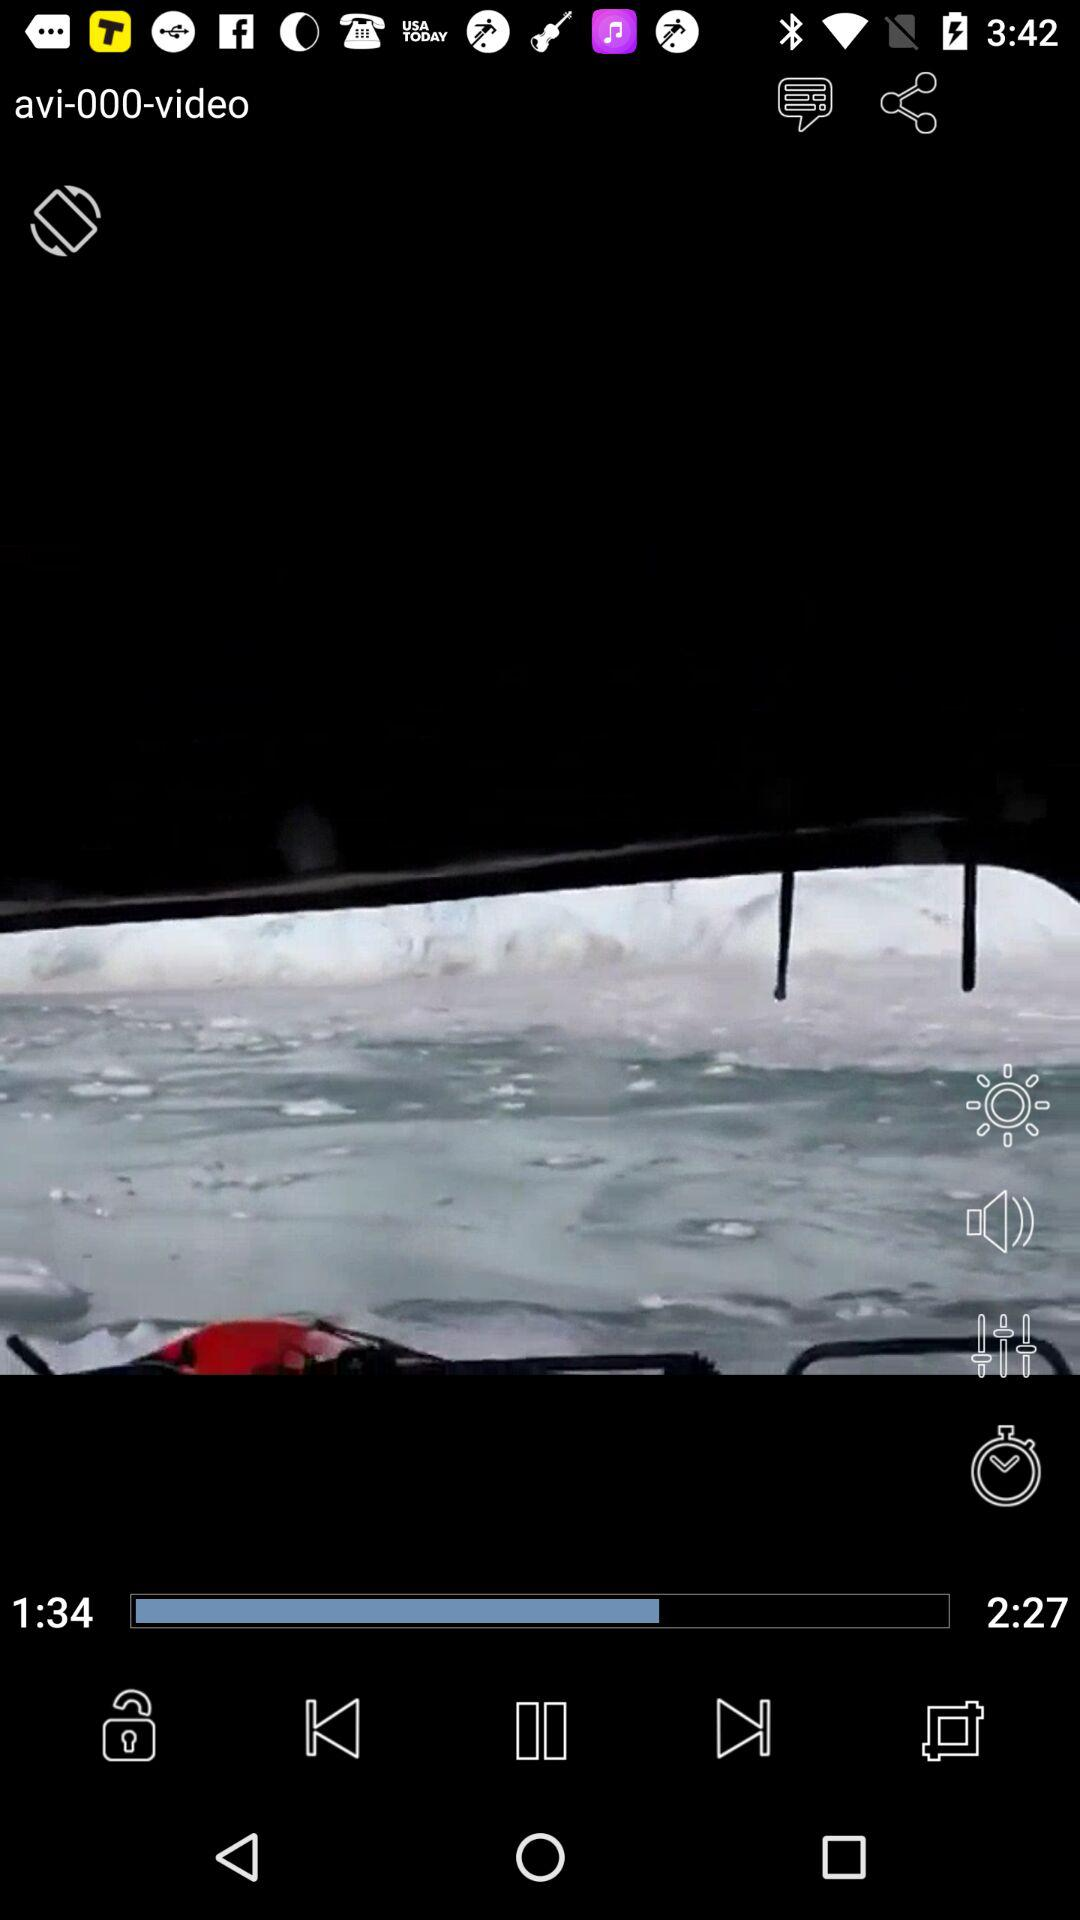What is the duration of the "avi-000-video" video? The duration of the "avi-000-video" video is 2 minutes 27 seconds. 